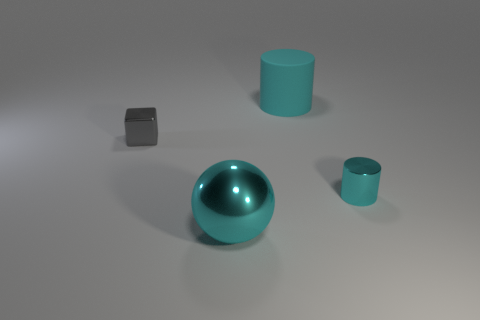Add 1 big gray matte cylinders. How many objects exist? 5 Subtract 1 gray blocks. How many objects are left? 3 Subtract all cubes. How many objects are left? 3 Subtract all gray spheres. Subtract all cyan cylinders. How many spheres are left? 1 Subtract all tiny yellow balls. Subtract all large cyan shiny balls. How many objects are left? 3 Add 3 tiny cyan cylinders. How many tiny cyan cylinders are left? 4 Add 4 large cyan matte cylinders. How many large cyan matte cylinders exist? 5 